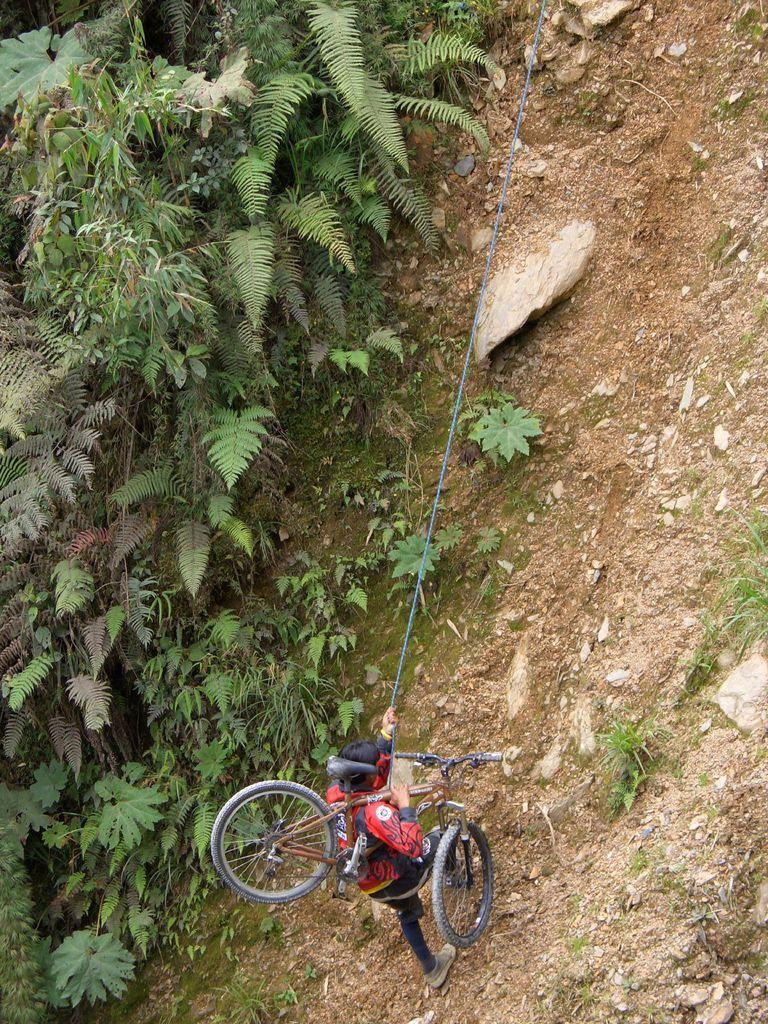Who is present in the image? There is a man in the image. What is the man doing in the image? The man is walking on the ground in the image. What is the man holding in the image? The man is holding a cycle in the image. What can be seen on the left side of the image? There are plants on the left side of the image. What type of ground surface is visible in the image? There are stones and sand on the ground in the image. What type of rake is being used to clean the sand in the image? There is no rake present in the image; the man is walking and holding a cycle. What kind of bait is the man using to catch fish in the image? There is no fishing or bait present in the image; the man is walking and holding a cycle. 